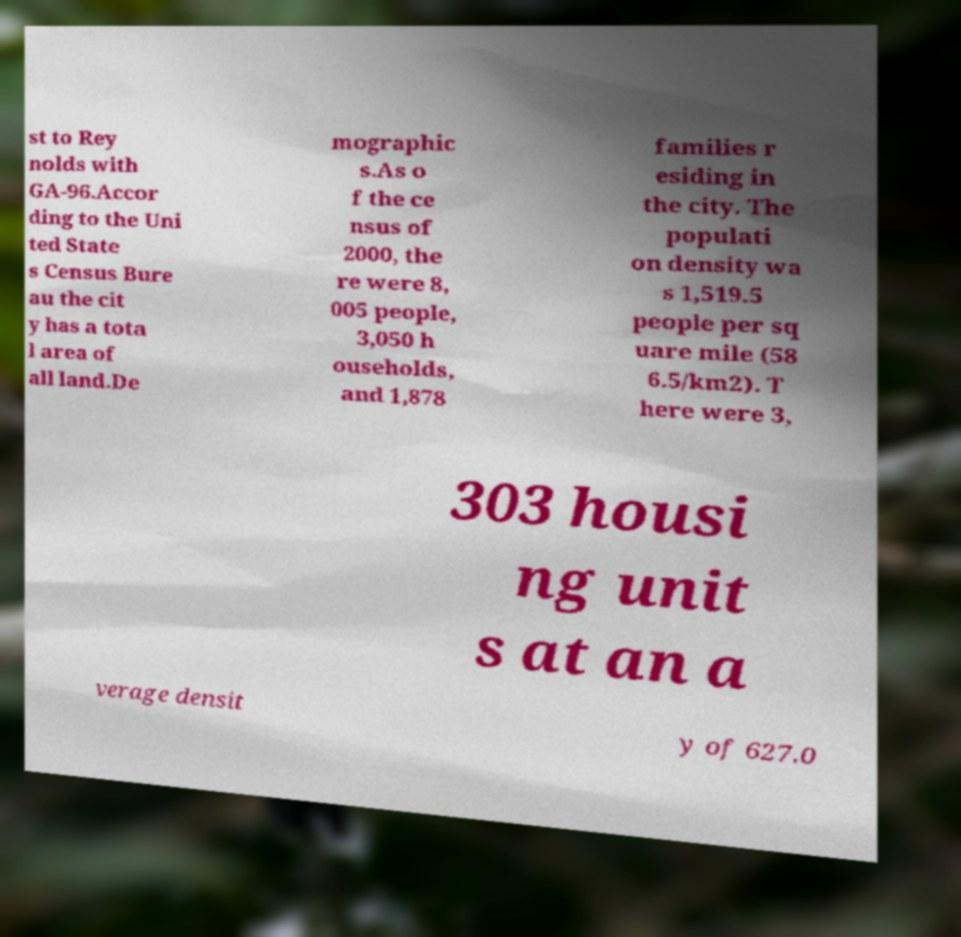Can you accurately transcribe the text from the provided image for me? st to Rey nolds with GA-96.Accor ding to the Uni ted State s Census Bure au the cit y has a tota l area of all land.De mographic s.As o f the ce nsus of 2000, the re were 8, 005 people, 3,050 h ouseholds, and 1,878 families r esiding in the city. The populati on density wa s 1,519.5 people per sq uare mile (58 6.5/km2). T here were 3, 303 housi ng unit s at an a verage densit y of 627.0 